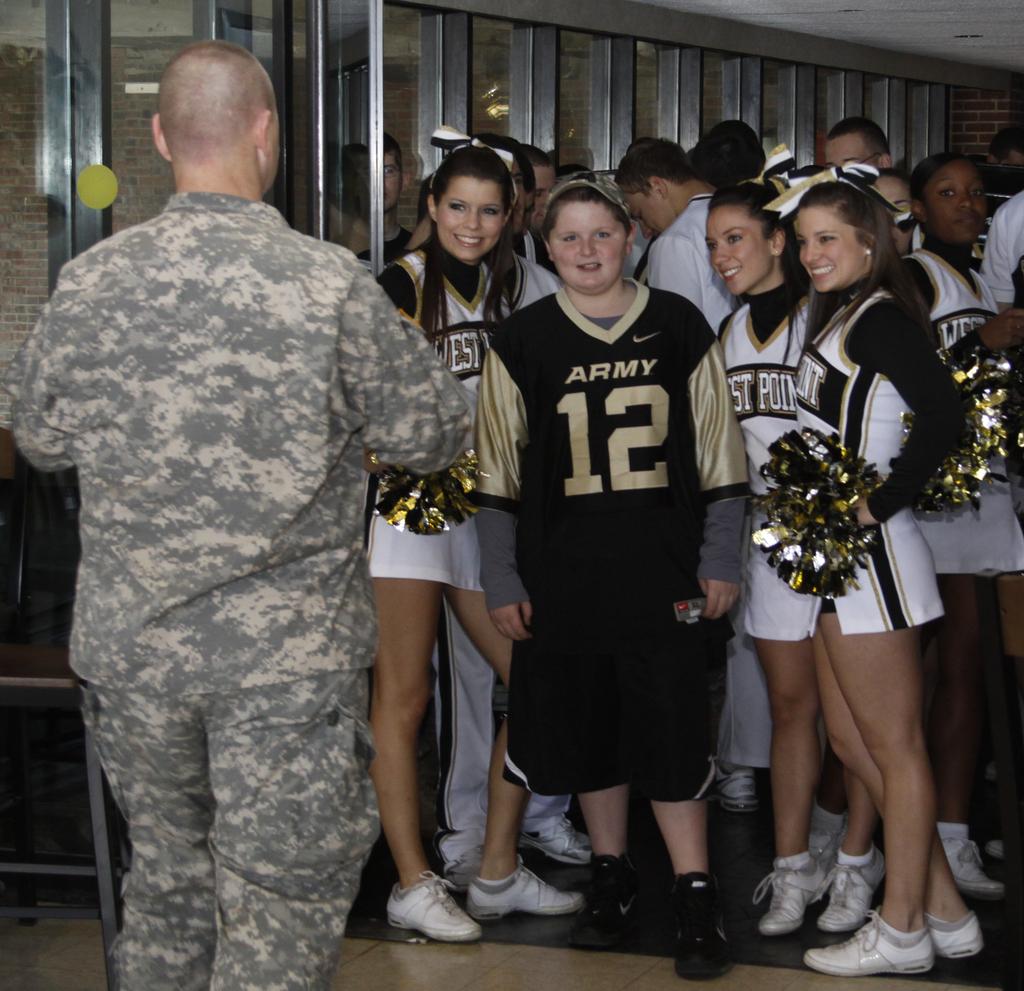What is the number on the second girl's t-shirt?
Ensure brevity in your answer.  12. What branch of the military is this boy supporting?
Your answer should be compact. Army. 